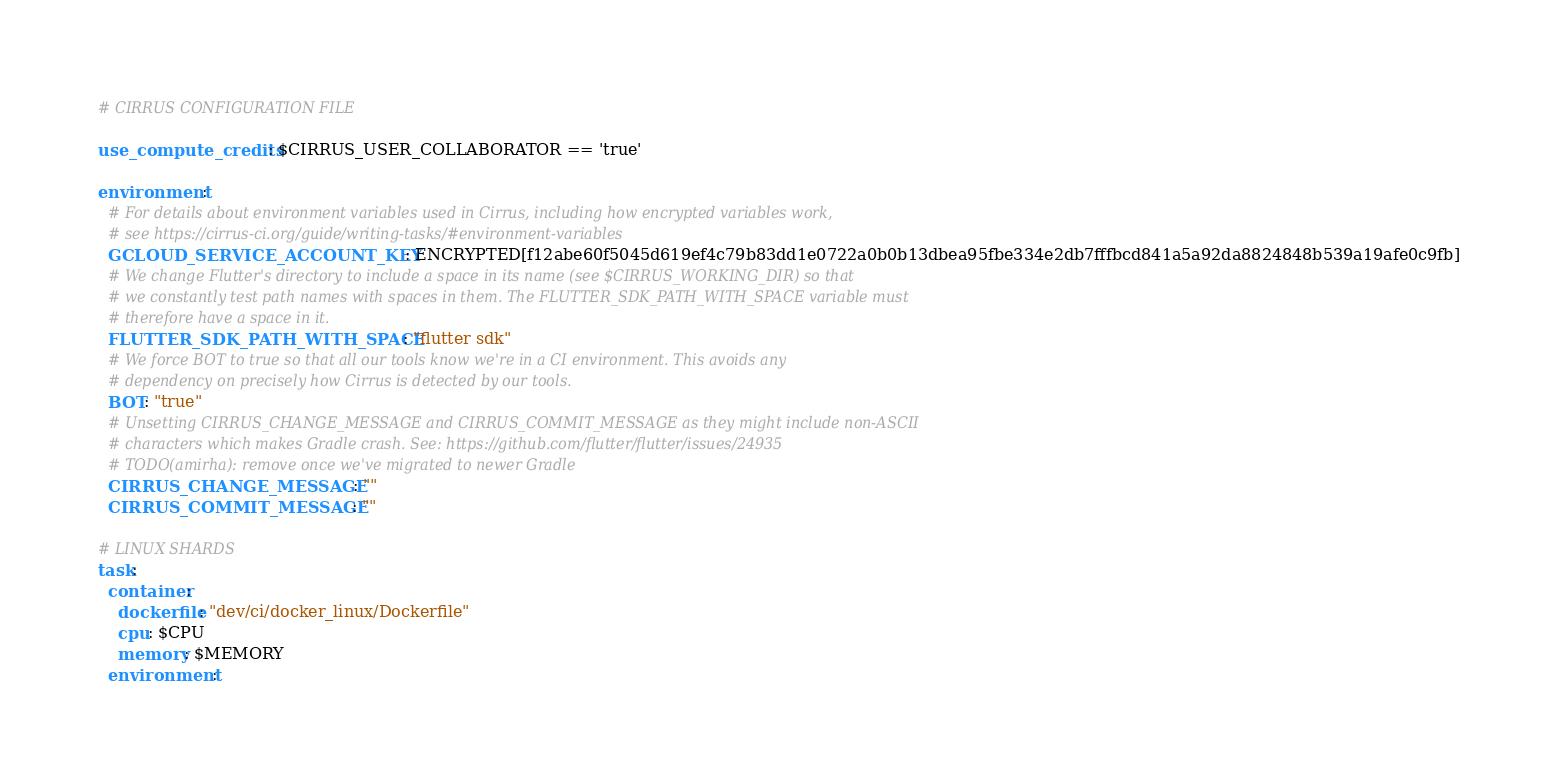<code> <loc_0><loc_0><loc_500><loc_500><_YAML_># CIRRUS CONFIGURATION FILE

use_compute_credits: $CIRRUS_USER_COLLABORATOR == 'true'

environment:
  # For details about environment variables used in Cirrus, including how encrypted variables work,
  # see https://cirrus-ci.org/guide/writing-tasks/#environment-variables
  GCLOUD_SERVICE_ACCOUNT_KEY: ENCRYPTED[f12abe60f5045d619ef4c79b83dd1e0722a0b0b13dbea95fbe334e2db7fffbcd841a5a92da8824848b539a19afe0c9fb]
  # We change Flutter's directory to include a space in its name (see $CIRRUS_WORKING_DIR) so that
  # we constantly test path names with spaces in them. The FLUTTER_SDK_PATH_WITH_SPACE variable must
  # therefore have a space in it.
  FLUTTER_SDK_PATH_WITH_SPACE: "flutter sdk"
  # We force BOT to true so that all our tools know we're in a CI environment. This avoids any
  # dependency on precisely how Cirrus is detected by our tools.
  BOT: "true"
  # Unsetting CIRRUS_CHANGE_MESSAGE and CIRRUS_COMMIT_MESSAGE as they might include non-ASCII
  # characters which makes Gradle crash. See: https://github.com/flutter/flutter/issues/24935
  # TODO(amirha): remove once we've migrated to newer Gradle
  CIRRUS_CHANGE_MESSAGE: ""
  CIRRUS_COMMIT_MESSAGE: ""

# LINUX SHARDS
task:
  container:
    dockerfile: "dev/ci/docker_linux/Dockerfile"
    cpu: $CPU
    memory: $MEMORY
  environment:</code> 